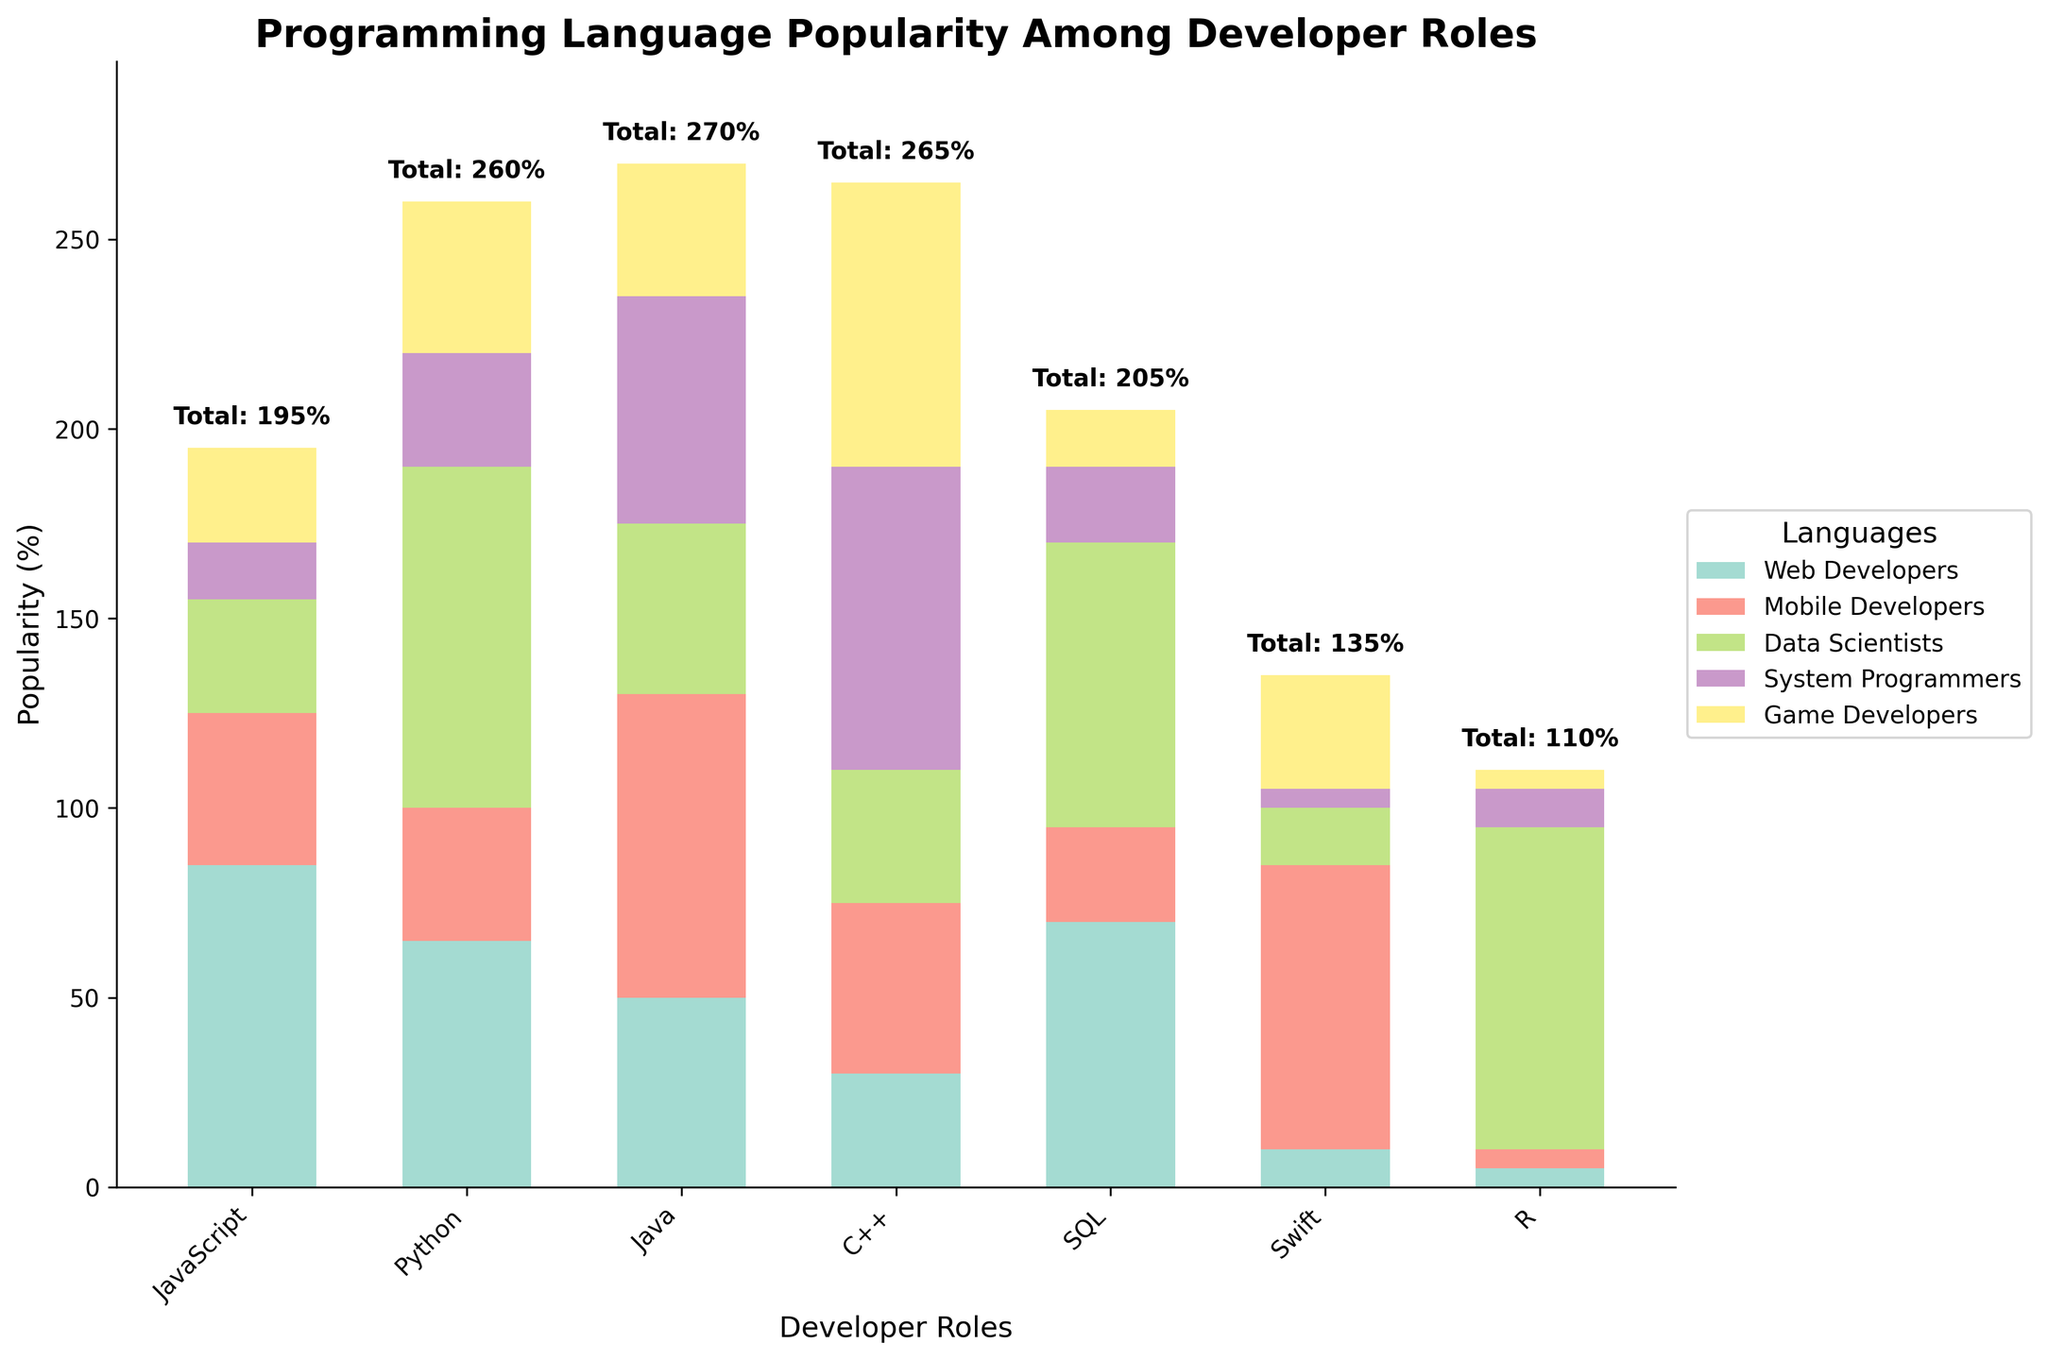What is the title of the chart? The chart has a clear title at the top which is meant to provide an overview of what the chart represents.
Answer: Programming Language Popularity Among Developer Roles Which two developer roles have the highest total popularity percentages? To answer this, look at the top of each bar where the total percentages are marked, and identify the two highest.
Answer: Web Developers, Data Scientists Which programming language is most popular among Web Developers? Look at the corresponding section of the bar for Web Developers and identify the label with the highest value.
Answer: JavaScript What is the sum of the popularity percentages for SQL and Java among Data Scientists? Find the segments for SQL and Java in the Data Scientists bar and add their values together: 75 (SQL) + 45 (Java).
Answer: 120 Which language has almost equal popularity among System Programmers and Game Developers but a lower popularity among Web Developers? Identify the language with similar heights in the System Programmers and Game Developers bars and compare with the Web Developers bar.
Answer: C++ Which developer role shows the greatest preference for Python? Look at the relative heights of the segments for Python across all developer roles and identify the one where Python is the highest.
Answer: Data Scientists Among Game Developers, which two languages are least popular? In the Game Developers bar, identify the two segments with the smallest heights.
Answer: R, SQL Is R more popular among Data Scientists or Mobile Developers? Compare the height of the R segment in the Data Scientists bar versus the Mobile Developers bar.
Answer: Data Scientists What is the difference in the popularity of Swift between Mobile Developers and System Programmers? Find the segments for Swift in the Mobile Developers and System Programmers bars and subtract their values: 75 (Mobile Developers) - 5 (System Programmers).
Answer: 70 Which developer role has the smallest range of popularity percentages among all programming languages? Calculate the difference between the highest and lowest values for each role, then find the role with the smallest difference.
Answer: Game Developers 